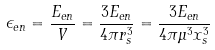<formula> <loc_0><loc_0><loc_500><loc_500>\epsilon _ { e n } = \frac { E _ { e n } } { V } = \frac { 3 E _ { e n } } { 4 \pi r _ { s } ^ { 3 } } = \frac { 3 E _ { e n } } { 4 \pi \mu ^ { 3 } x _ { s } ^ { 3 } }</formula> 